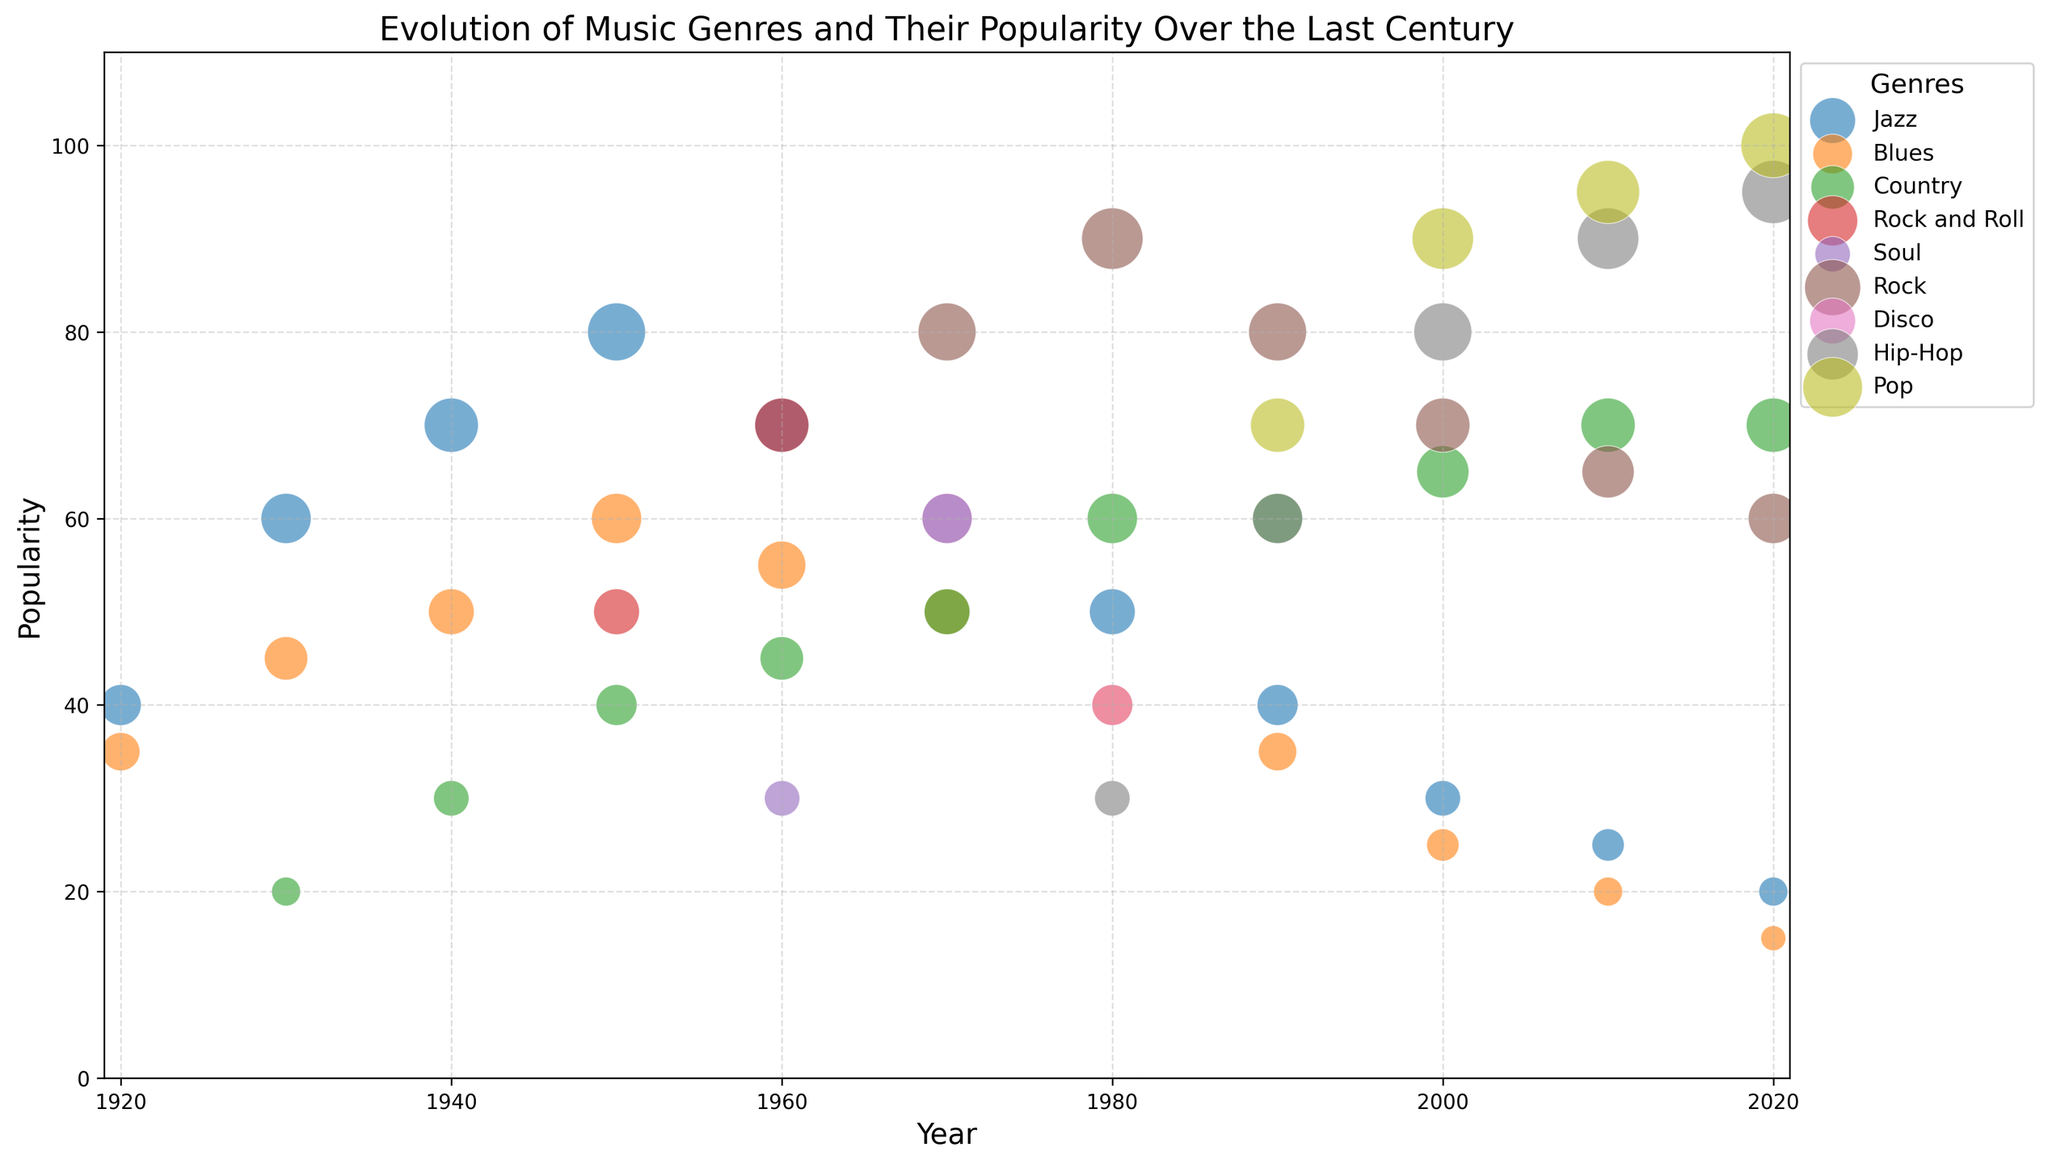What genre had the highest popularity in 2020? Look for the largest bubble in the year 2020. The largest bubble corresponds to the Pop genre.
Answer: Pop How did the popularity of Jazz change from 1920 to 2020? Compare the bubble sizes and positions for Jazz from 1920 to 2020. The popularity decreased from 40 in 1920 to 20 in 2020.
Answer: Decreased Which genre saw the most significant rise in popularity between 2000 and 2020? Compare the bubble sizes of each genre between 2000 and 2020. Hip-Hop's popularity increased the most, from 80 in 2000 to 95 in 2020.
Answer: Hip-Hop What was the average popularity of Rock and Roll/Rock across all the years on the chart? Calculate the average of the popularity values for Rock and Roll/Rock across all years: (50 + 70 + 80 + 90 + 70 + 80 + 65 + 60)/8.
Answer: 70.6 Which genre had higher popularity in the 1960s, Jazz or Rock and Roll? Compare the bubble sizes of Jazz and Rock and Roll in the year 1960. Jazz had a popularity of 70, while Rock and Roll also had a popularity of 70.
Answer: Equal Did any genre have a consistent increase in popularity every decade from 1940 to 2020? Examine the trends for all genres. Pop gradually increased its popularity in each decade from 1940 to 2020.
Answer: Pop What is the difference in popularity between the most and the least popular genres in 1980? Identify the genres with the largest and smallest bubbles in 1980. Rock had the highest popularity at 90, and Blues had the lowest at 40. The difference is 90 - 40.
Answer: 50 What decade saw the introduction of the most new music genres? Look for the first appearance of new genres in each decade. The 1950s saw the introduction of two new genres: Rock and Roll and Soul.
Answer: 1950s Which genre had a peak popularity and then a decline over the decades? Examine each genre for a peak followed by a decline. Jazz had its peak in popularity around the 1950s and then declined.
Answer: Jazz From the 1990s to 2020, which genre saw a decrease in popularity, and by how much? Compare the popularity values between 1990 and 2020 for each genre. Jazz declined from 40 in 1990 to 20 in 2020, a decrease of 20.
Answer: Jazz, 20 